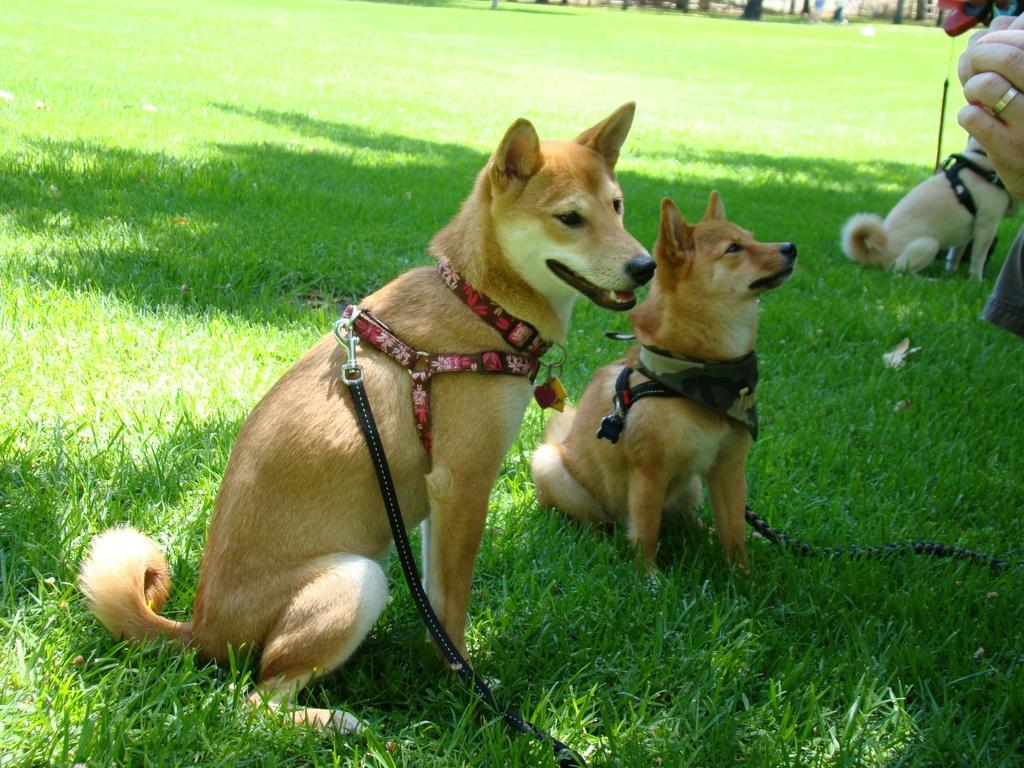How many dogs are present in the image? There are three dogs in the image. What are the dogs wearing in the image? The dogs are wearing belts in the image. Can you describe any human presence in the image? There is a person's hand visible in the image. What type of environment is depicted in the background of the image? There is grass in the background of the image. Where is the library located in the image? There is no library present in the image. Can you describe the harbor in the image? There is no harbor present in the image. 